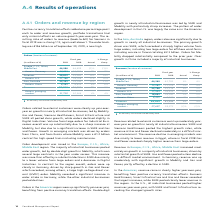According to Siemens Ag's financial document, What caused the Revenue related to external customers to go up? Based on the financial document, the answer is Revenue related to external customers went up moderately yearover- year on growth in nearly all industrial businesses. Also, What caused the increase in the Revenue in Europe, C. I. S., Africa, Middle East? Based on the financial document, the answer is Revenue in Europe, C. I. S., Africa, Middle East increased moderately on growth in a majority of industrial businesses, driven by substantial growth at SGRE. Also, What caused the increase in revenue in Americas? Based on the financial document, the answer is In the Americas, revenue came in clearly higher year-over-year, benefiting from positive currency translation effects. Also, can you calculate: What was the average orders in the Americas region in 2019 and 2018? To answer this question, I need to perform calculations using the financial data. The calculation is: (23,796 + 22,115) / 2, which equals 22955.5 (in millions). This is based on the information: "Americas 23,796 22,115 8 % 3 % Americas 23,796 22,115 8 % 3 %..." The key data points involved are: 22,115, 23,796. Also, can you calculate: What is the increase / (decrease) in the orders for Asia and Australia from 2018 to 2019? Based on the calculation: 18,693 - 18,147, the result is 546 (in millions). This is based on the information: "Asia, Australia 18,693 18,147 3 % 2 % Asia, Australia 18,693 18,147 3 % 2 %..." The key data points involved are: 18,147, 18,693. Also, can you calculate: What is the percentage increase in the orders for Siemens from 2019 to 2018? To answer this question, I need to perform calculations using the financial data. The calculation is: 86,849 / 83,044 - 1, which equals 4.58 (percentage). This is based on the information: "Siemens 86,849 83,044 5 % 3 % Siemens 86,849 83,044 5 % 3 %..." The key data points involved are: 83,044, 86,849. 